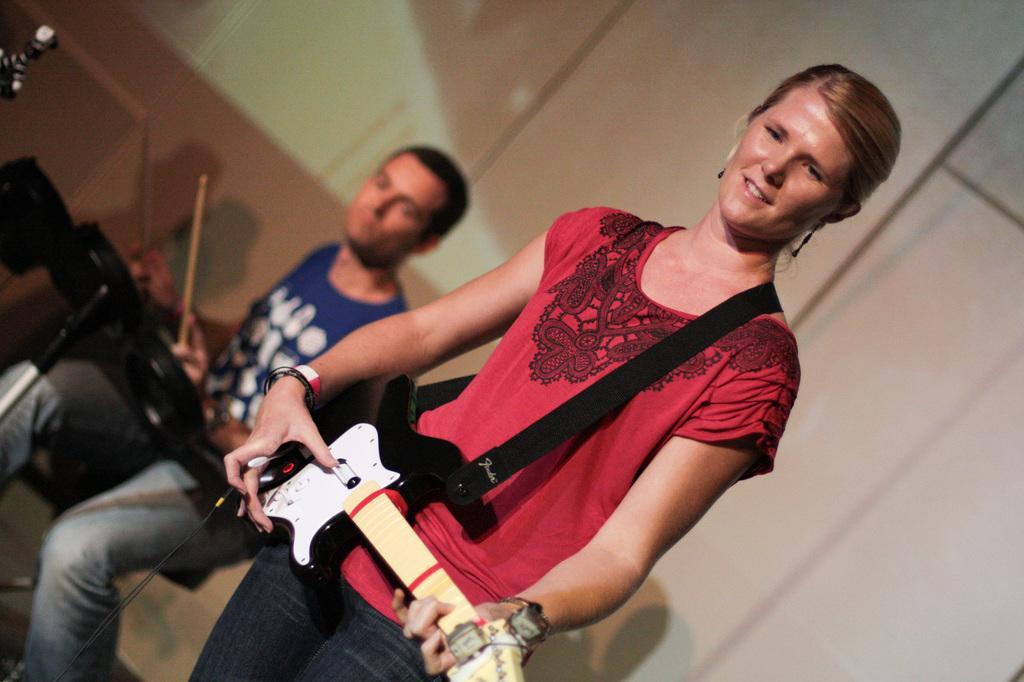How would you summarize this image in a sentence or two? Here is a woman playing black color guitar wearing a bracelet of red and white,she is smiling,she is wearing black color ear rings. We can also see a person behind the woman wearing blue color shirt and playing drums holding the sticks in his both hands. In the background we can see a cream color wall. 